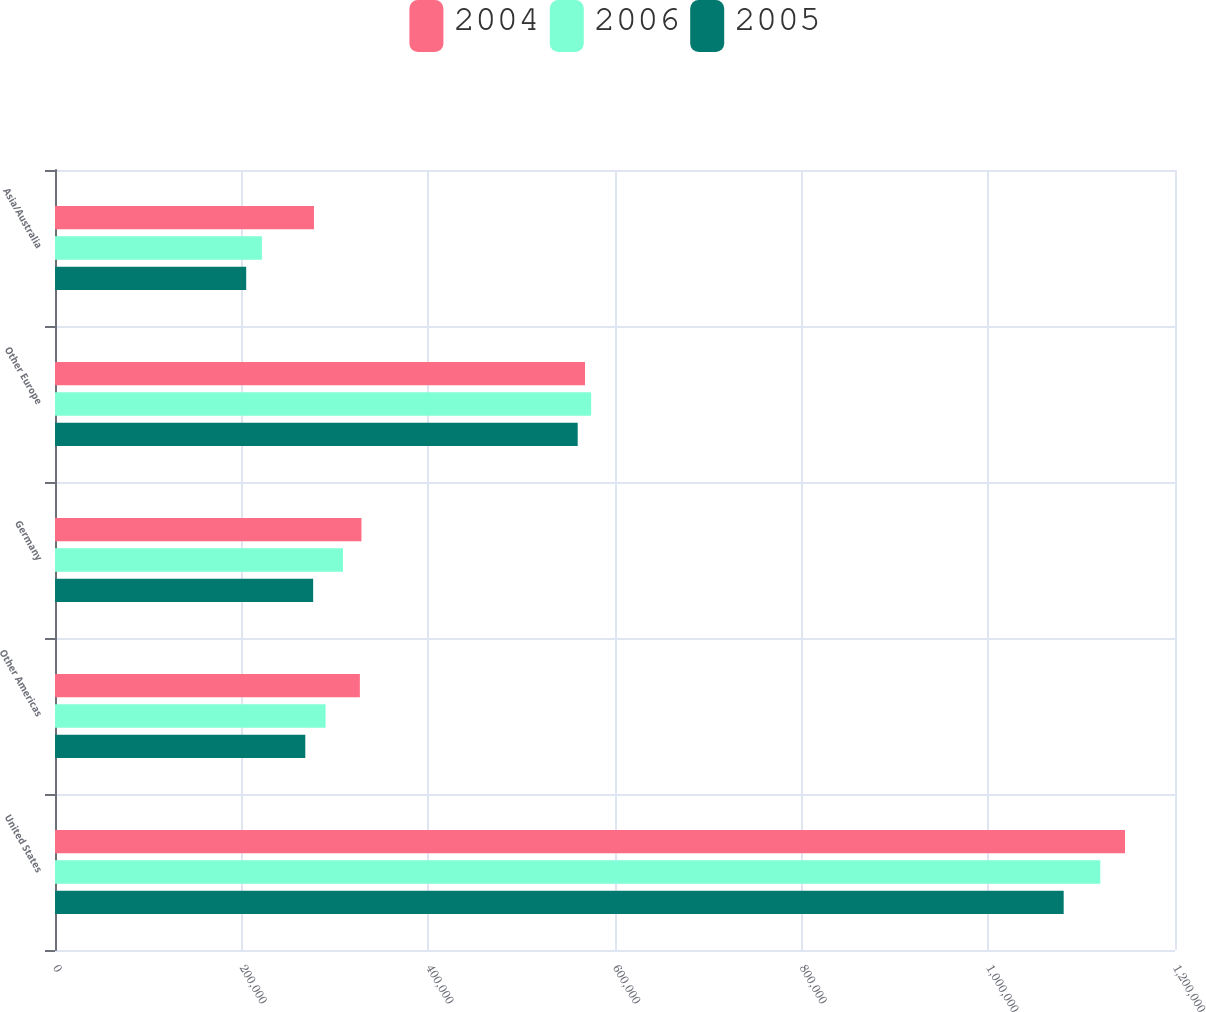Convert chart to OTSL. <chart><loc_0><loc_0><loc_500><loc_500><stacked_bar_chart><ecel><fcel>United States<fcel>Other Americas<fcel>Germany<fcel>Other Europe<fcel>Asia/Australia<nl><fcel>2004<fcel>1.14643e+06<fcel>326630<fcel>328355<fcel>567870<fcel>277468<nl><fcel>2006<fcel>1.11998e+06<fcel>289915<fcel>308536<fcel>574451<fcel>221672<nl><fcel>2005<fcel>1.08074e+06<fcel>268174<fcel>276611<fcel>560038<fcel>204853<nl></chart> 